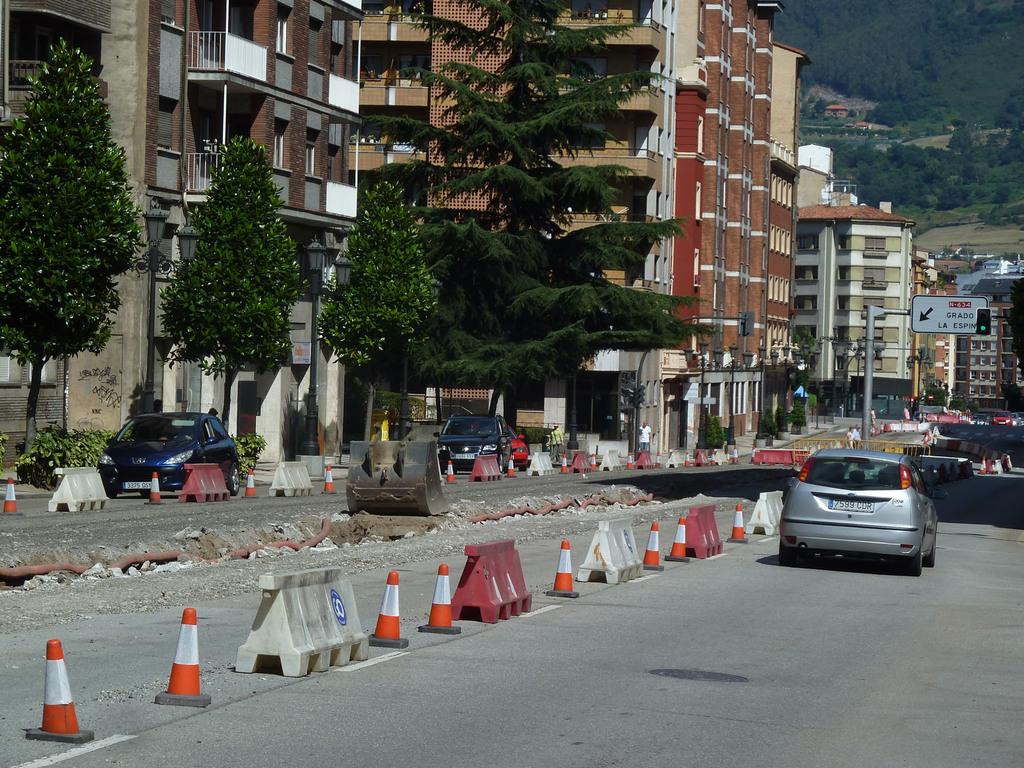What is happening in the middle of the image? There are vehicles moving on the road in the image. Where are the vehicles located in relation to the other elements in the image? The vehicles are in the middle of the image. What can be seen on the left side of the image? There are trees and buildings on the left side of the image. What type of juice is being served at the activity on the right side of the image? There is no activity or juice present on the right side of the image. How much dust can be seen in the image? There is no mention of dust in the image, so it cannot be determined how much dust is present. 